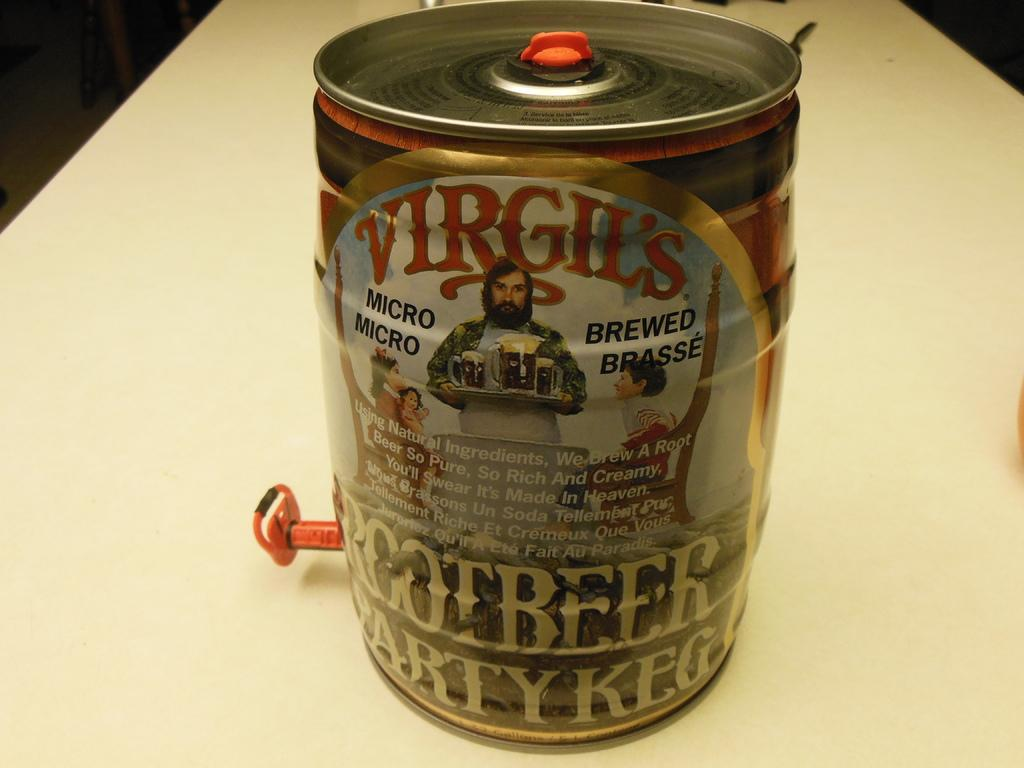Provide a one-sentence caption for the provided image. A party Keg of Virgil's micro brew will be served at the party. 